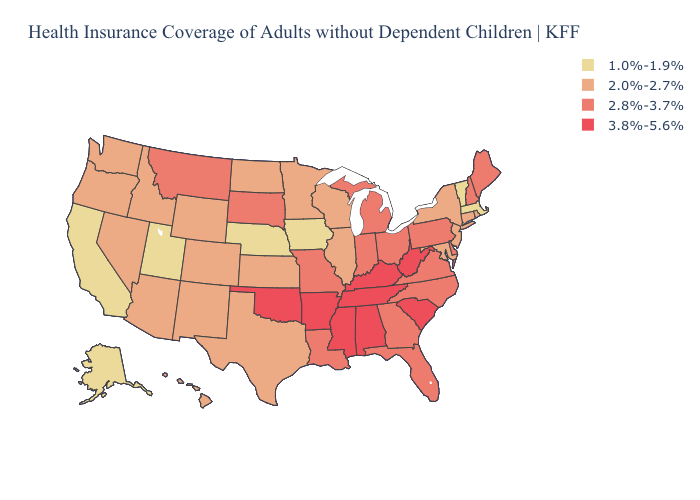Does Delaware have the lowest value in the USA?
Write a very short answer. No. Name the states that have a value in the range 2.0%-2.7%?
Concise answer only. Arizona, Colorado, Connecticut, Hawaii, Idaho, Illinois, Kansas, Maryland, Minnesota, Nevada, New Jersey, New Mexico, New York, North Dakota, Oregon, Rhode Island, Texas, Washington, Wisconsin, Wyoming. Does Colorado have a higher value than Illinois?
Concise answer only. No. What is the value of Georgia?
Concise answer only. 2.8%-3.7%. Name the states that have a value in the range 1.0%-1.9%?
Keep it brief. Alaska, California, Iowa, Massachusetts, Nebraska, Utah, Vermont. Which states hav the highest value in the South?
Keep it brief. Alabama, Arkansas, Kentucky, Mississippi, Oklahoma, South Carolina, Tennessee, West Virginia. What is the lowest value in the USA?
Keep it brief. 1.0%-1.9%. Does Arizona have the same value as California?
Be succinct. No. Does Pennsylvania have the highest value in the Northeast?
Write a very short answer. Yes. What is the value of Nevada?
Concise answer only. 2.0%-2.7%. What is the value of Georgia?
Give a very brief answer. 2.8%-3.7%. How many symbols are there in the legend?
Concise answer only. 4. What is the highest value in states that border South Carolina?
Be succinct. 2.8%-3.7%. What is the value of Idaho?
Be succinct. 2.0%-2.7%. Which states hav the highest value in the West?
Give a very brief answer. Montana. 